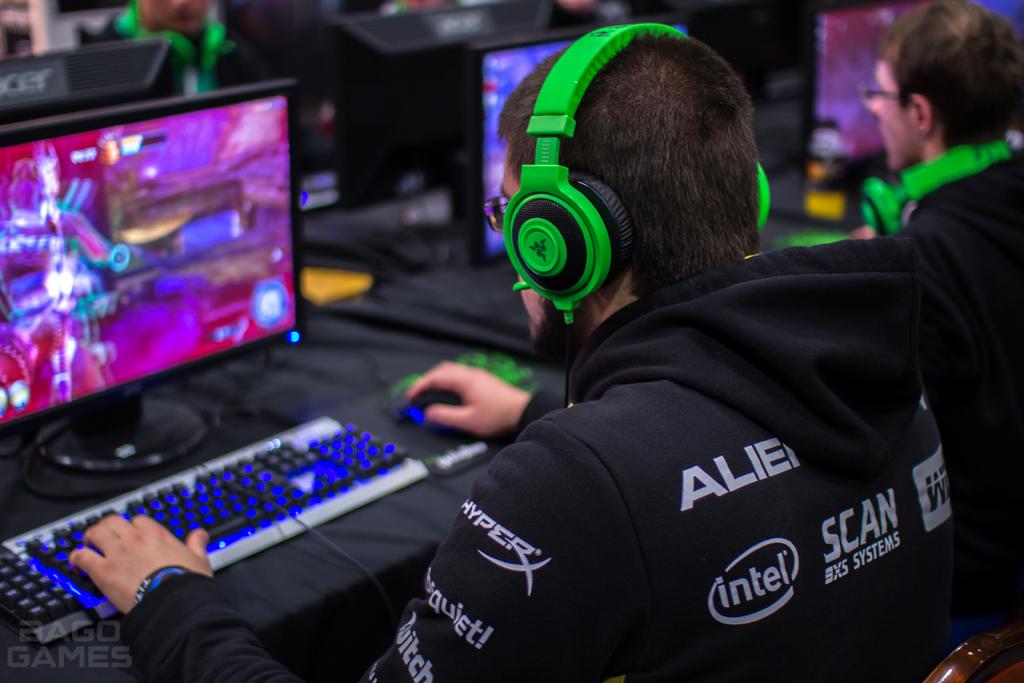Whats the first company sponsor is on the mans left sleeve?
Provide a short and direct response. Hyper. 